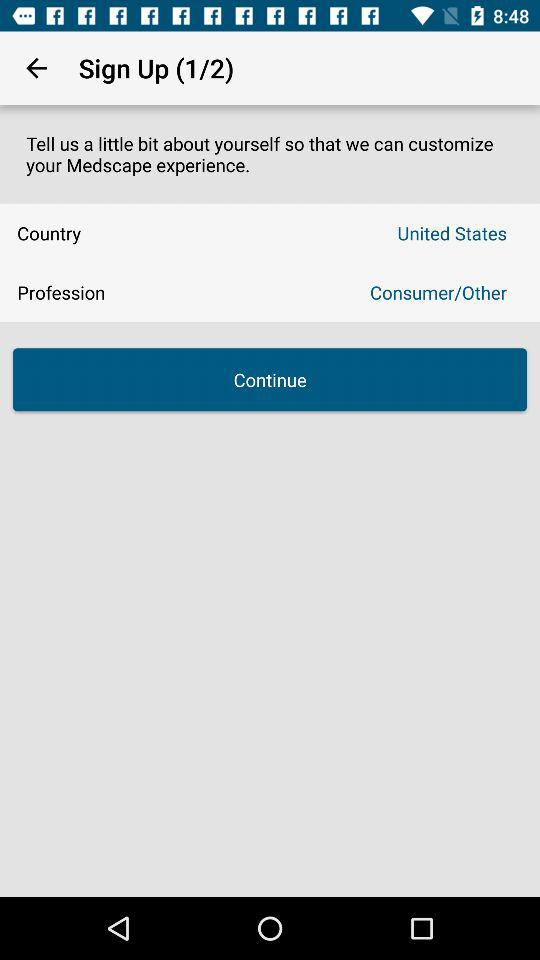At which step am I? You are at the first step. 